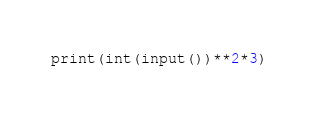Convert code to text. <code><loc_0><loc_0><loc_500><loc_500><_Python_>print(int(input())**2*3)</code> 